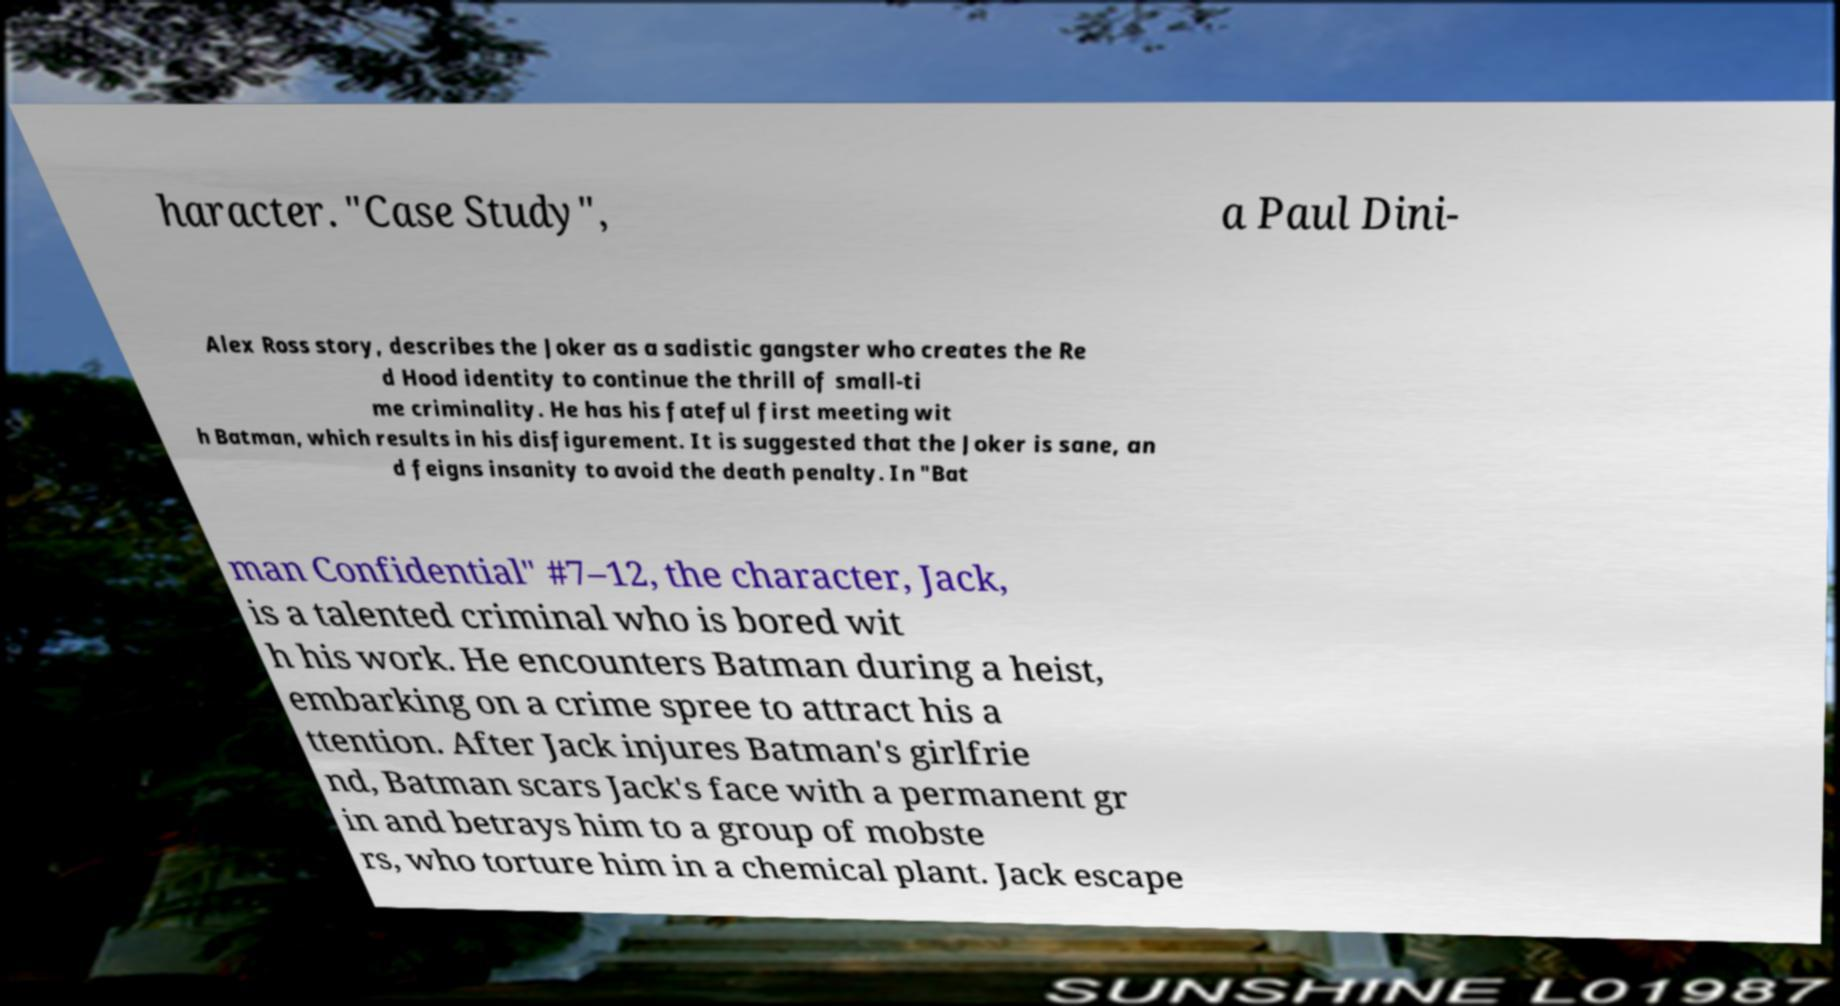Could you extract and type out the text from this image? haracter. "Case Study", a Paul Dini- Alex Ross story, describes the Joker as a sadistic gangster who creates the Re d Hood identity to continue the thrill of small-ti me criminality. He has his fateful first meeting wit h Batman, which results in his disfigurement. It is suggested that the Joker is sane, an d feigns insanity to avoid the death penalty. In "Bat man Confidential" #7–12, the character, Jack, is a talented criminal who is bored wit h his work. He encounters Batman during a heist, embarking on a crime spree to attract his a ttention. After Jack injures Batman's girlfrie nd, Batman scars Jack's face with a permanent gr in and betrays him to a group of mobste rs, who torture him in a chemical plant. Jack escape 